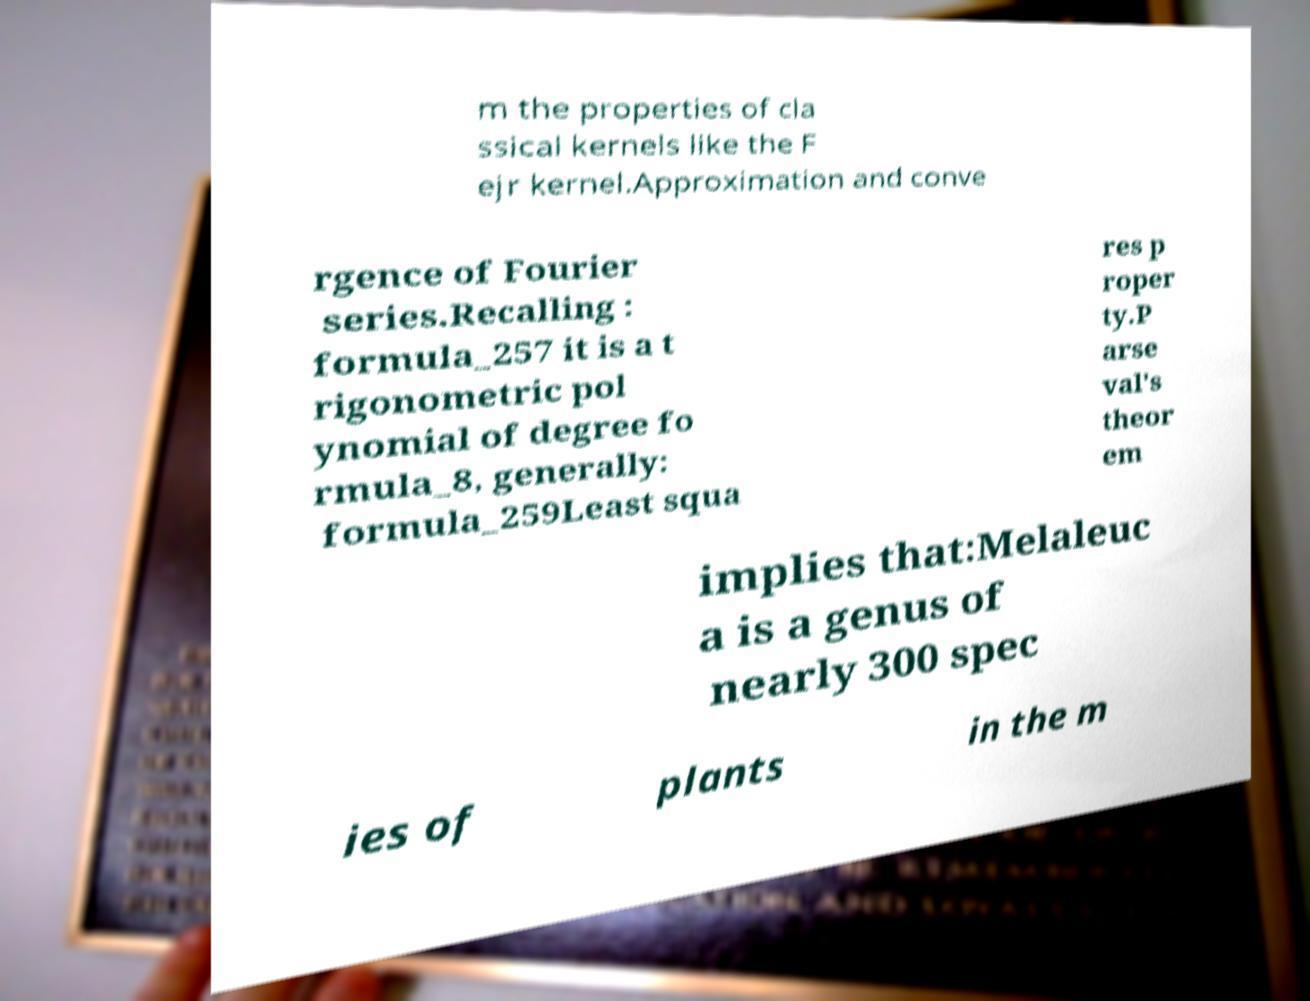Could you extract and type out the text from this image? m the properties of cla ssical kernels like the F ejr kernel.Approximation and conve rgence of Fourier series.Recalling : formula_257 it is a t rigonometric pol ynomial of degree fo rmula_8, generally: formula_259Least squa res p roper ty.P arse val's theor em implies that:Melaleuc a is a genus of nearly 300 spec ies of plants in the m 